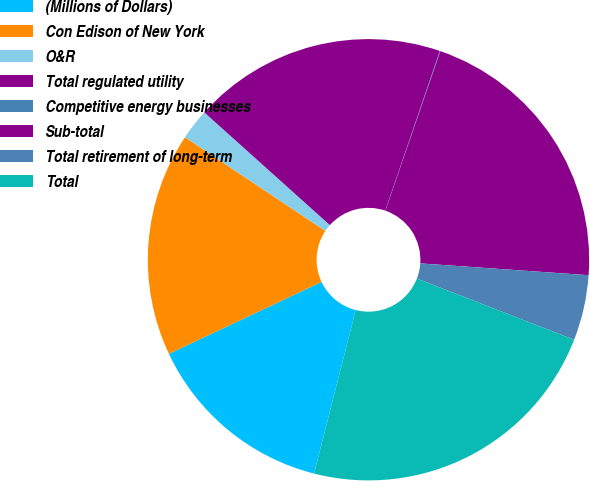Convert chart. <chart><loc_0><loc_0><loc_500><loc_500><pie_chart><fcel>(Millions of Dollars)<fcel>Con Edison of New York<fcel>O&R<fcel>Total regulated utility<fcel>Competitive energy businesses<fcel>Sub-total<fcel>Total retirement of long-term<fcel>Total<nl><fcel>14.02%<fcel>16.38%<fcel>2.27%<fcel>18.6%<fcel>0.04%<fcel>20.83%<fcel>4.79%<fcel>23.06%<nl></chart> 